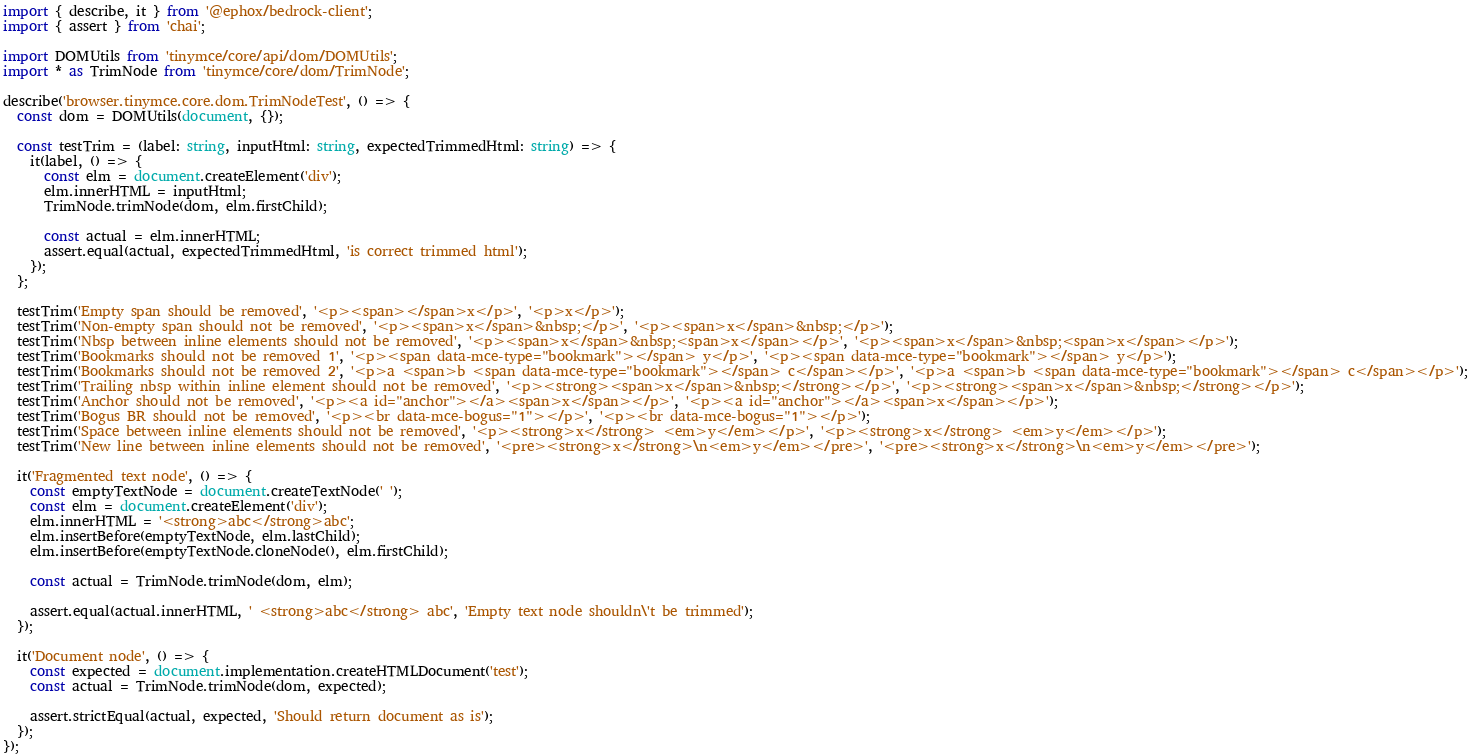<code> <loc_0><loc_0><loc_500><loc_500><_TypeScript_>import { describe, it } from '@ephox/bedrock-client';
import { assert } from 'chai';

import DOMUtils from 'tinymce/core/api/dom/DOMUtils';
import * as TrimNode from 'tinymce/core/dom/TrimNode';

describe('browser.tinymce.core.dom.TrimNodeTest', () => {
  const dom = DOMUtils(document, {});

  const testTrim = (label: string, inputHtml: string, expectedTrimmedHtml: string) => {
    it(label, () => {
      const elm = document.createElement('div');
      elm.innerHTML = inputHtml;
      TrimNode.trimNode(dom, elm.firstChild);

      const actual = elm.innerHTML;
      assert.equal(actual, expectedTrimmedHtml, 'is correct trimmed html');
    });
  };

  testTrim('Empty span should be removed', '<p><span></span>x</p>', '<p>x</p>');
  testTrim('Non-empty span should not be removed', '<p><span>x</span>&nbsp;</p>', '<p><span>x</span>&nbsp;</p>');
  testTrim('Nbsp between inline elements should not be removed', '<p><span>x</span>&nbsp;<span>x</span></p>', '<p><span>x</span>&nbsp;<span>x</span></p>');
  testTrim('Bookmarks should not be removed 1', '<p><span data-mce-type="bookmark"></span> y</p>', '<p><span data-mce-type="bookmark"></span> y</p>');
  testTrim('Bookmarks should not be removed 2', '<p>a <span>b <span data-mce-type="bookmark"></span> c</span></p>', '<p>a <span>b <span data-mce-type="bookmark"></span> c</span></p>');
  testTrim('Trailing nbsp within inline element should not be removed', '<p><strong><span>x</span>&nbsp;</strong></p>', '<p><strong><span>x</span>&nbsp;</strong></p>');
  testTrim('Anchor should not be removed', '<p><a id="anchor"></a><span>x</span></p>', '<p><a id="anchor"></a><span>x</span></p>');
  testTrim('Bogus BR should not be removed', '<p><br data-mce-bogus="1"></p>', '<p><br data-mce-bogus="1"></p>');
  testTrim('Space between inline elements should not be removed', '<p><strong>x</strong> <em>y</em></p>', '<p><strong>x</strong> <em>y</em></p>');
  testTrim('New line between inline elements should not be removed', '<pre><strong>x</strong>\n<em>y</em></pre>', '<pre><strong>x</strong>\n<em>y</em></pre>');

  it('Fragmented text node', () => {
    const emptyTextNode = document.createTextNode(' ');
    const elm = document.createElement('div');
    elm.innerHTML = '<strong>abc</strong>abc';
    elm.insertBefore(emptyTextNode, elm.lastChild);
    elm.insertBefore(emptyTextNode.cloneNode(), elm.firstChild);

    const actual = TrimNode.trimNode(dom, elm);

    assert.equal(actual.innerHTML, ' <strong>abc</strong> abc', 'Empty text node shouldn\'t be trimmed');
  });

  it('Document node', () => {
    const expected = document.implementation.createHTMLDocument('test');
    const actual = TrimNode.trimNode(dom, expected);

    assert.strictEqual(actual, expected, 'Should return document as is');
  });
});
</code> 